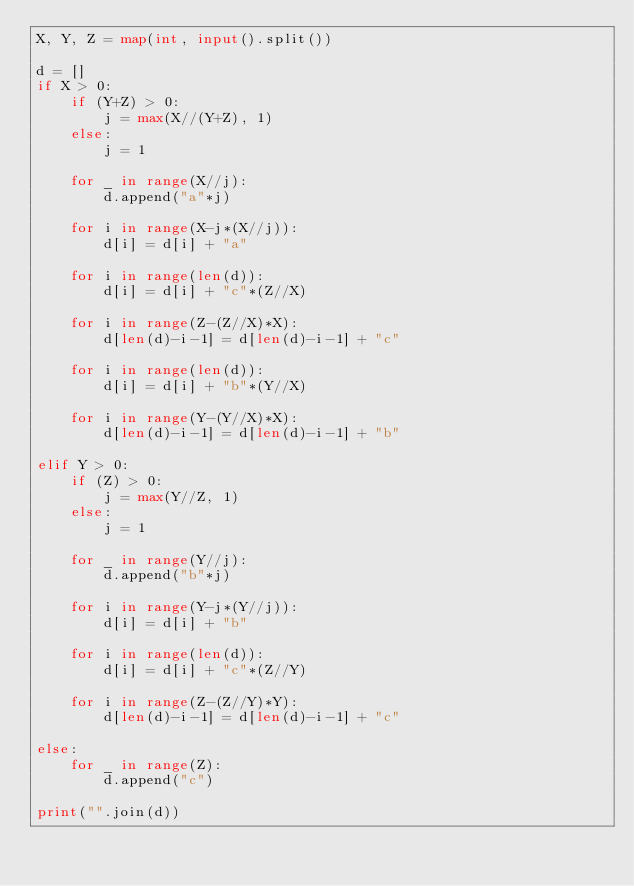Convert code to text. <code><loc_0><loc_0><loc_500><loc_500><_Python_>X, Y, Z = map(int, input().split())

d = []
if X > 0:
    if (Y+Z) > 0: 
        j = max(X//(Y+Z), 1)
    else:
        j = 1
    
    for _ in range(X//j):
        d.append("a"*j)
        
    for i in range(X-j*(X//j)):
        d[i] = d[i] + "a"
    
    for i in range(len(d)):
        d[i] = d[i] + "c"*(Z//X)
    
    for i in range(Z-(Z//X)*X):
        d[len(d)-i-1] = d[len(d)-i-1] + "c"
        
    for i in range(len(d)):
        d[i] = d[i] + "b"*(Y//X)
    
    for i in range(Y-(Y//X)*X):
        d[len(d)-i-1] = d[len(d)-i-1] + "b"
    
elif Y > 0:
    if (Z) > 0: 
        j = max(Y//Z, 1)
    else:
        j = 1
    
    for _ in range(Y//j):
        d.append("b"*j)
        
    for i in range(Y-j*(Y//j)):
        d[i] = d[i] + "b"    
    
    for i in range(len(d)):
        d[i] = d[i] + "c"*(Z//Y)
    
    for i in range(Z-(Z//Y)*Y):
        d[len(d)-i-1] = d[len(d)-i-1] + "c"
        
else:
    for _ in range(Z):
        d.append("c")

print("".join(d))</code> 